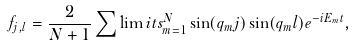Convert formula to latex. <formula><loc_0><loc_0><loc_500><loc_500>f _ { j , l } = \frac { 2 } { N + 1 } \sum \lim i t s _ { m = 1 } ^ { N } \sin ( q _ { m } j ) \sin ( q _ { m } l ) e ^ { - i E _ { m } t } ,</formula> 